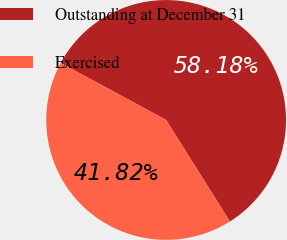Convert chart to OTSL. <chart><loc_0><loc_0><loc_500><loc_500><pie_chart><fcel>Outstanding at December 31<fcel>Exercised<nl><fcel>58.18%<fcel>41.82%<nl></chart> 